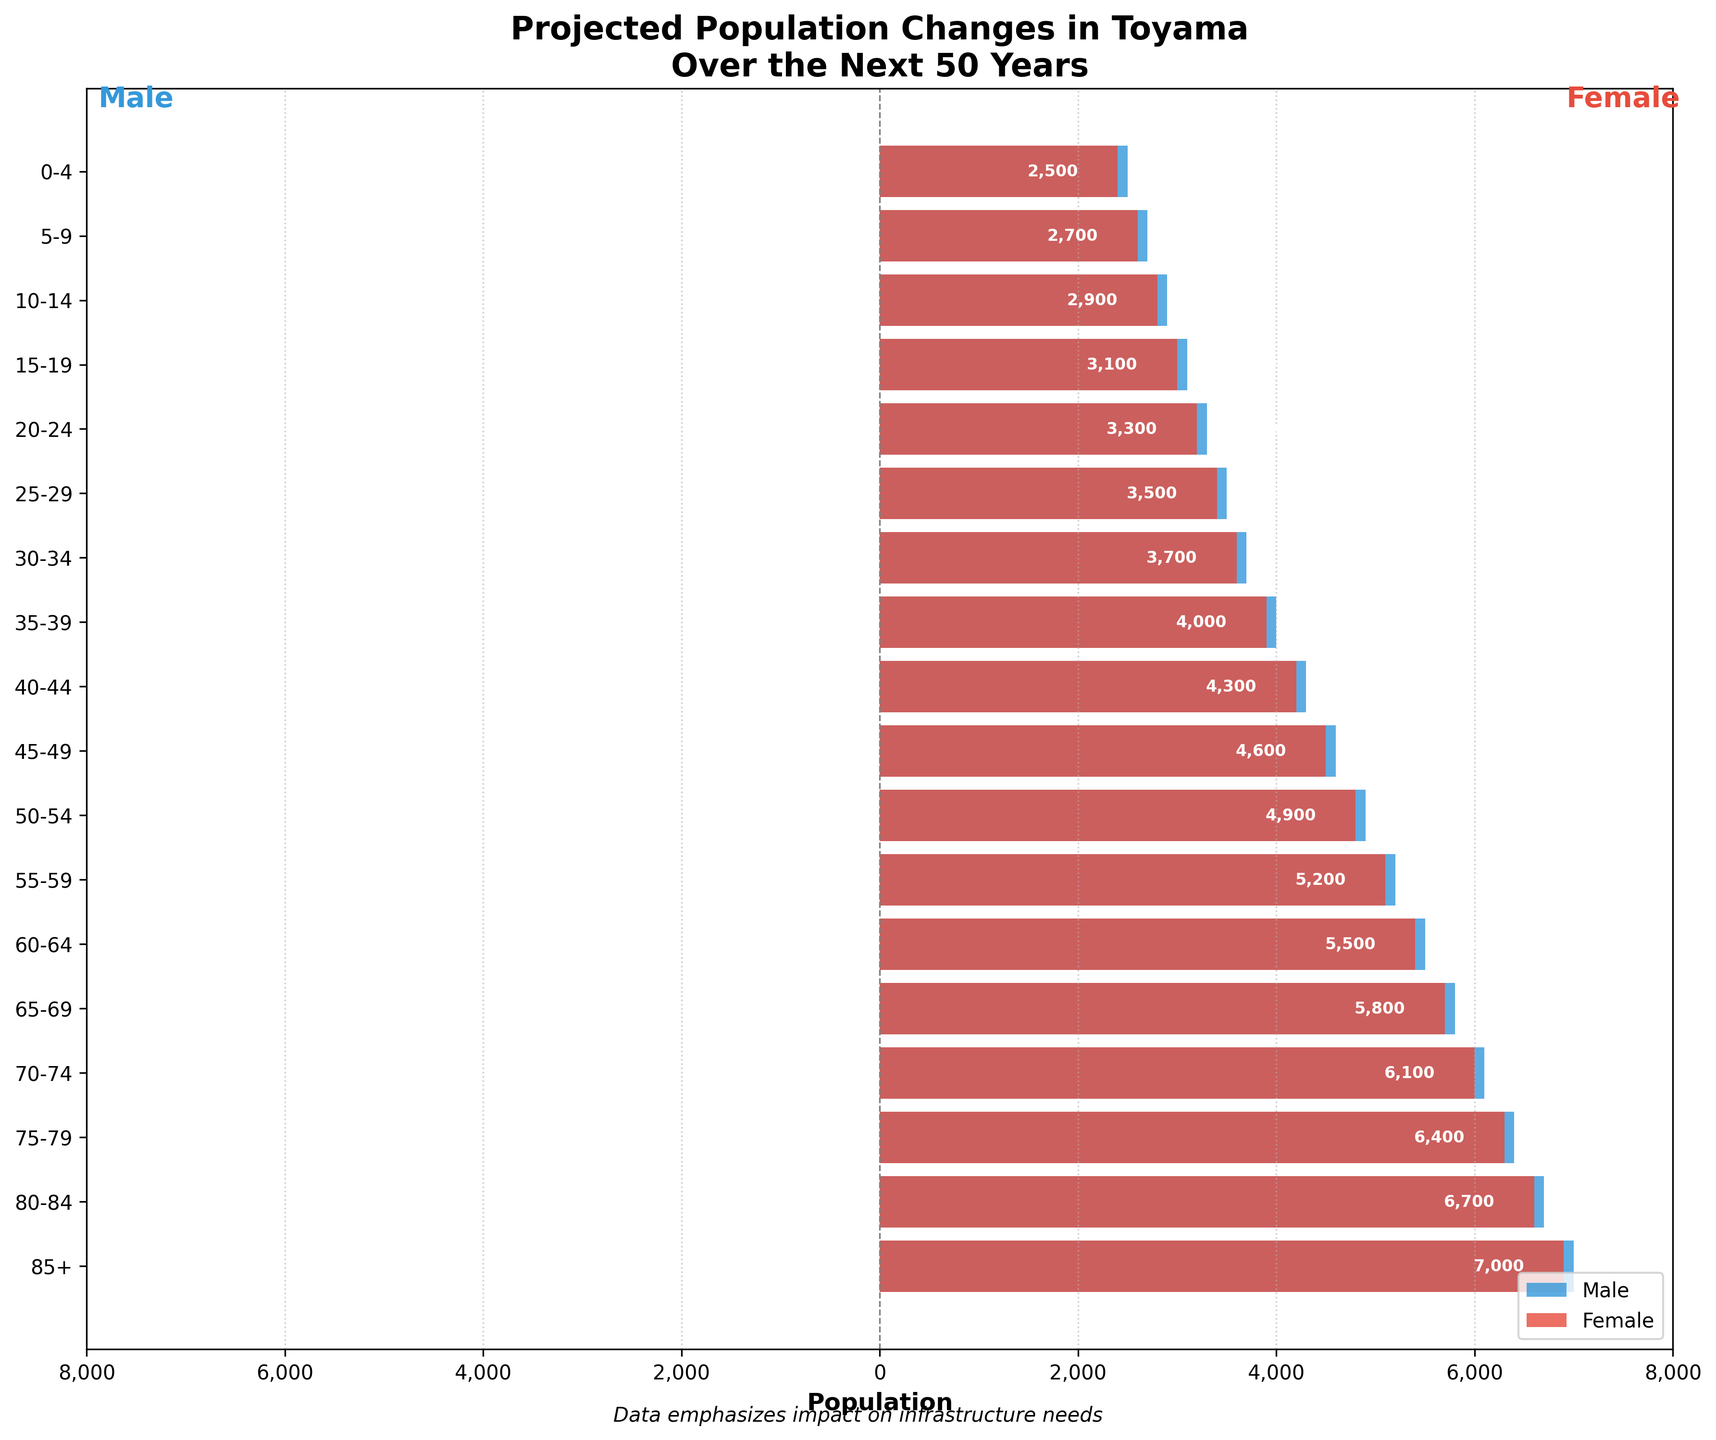What is the title of the figure? The title is usually displayed at the top of the figure.
Answer: Projected Population Changes in Toyama Over the Next 50 Years What is the population count for females in the age group 85+? Locate the bar corresponding to the age group 85+, then read the value at the end of the red (female) bar.
Answer: 6,900 How does the population of males in the 70-74 age group compare to that of females in the same age group? Locate the bars for the 70-74 age group. The left (blue) bar represents males and the right (red) bar represents females. The blue bar's value is -6,100, and the red bar's value is 6,000. The absolute values reveal the comparison.
Answer: Males have a slightly larger population than females Which age group has the highest population for males? Look at the length of the blue bars across all age groups. The longest blue bar corresponds to the age group with the highest male population.
Answer: 85+ Identify the age group that has nearly the same population for both males and females. Look for bars that are nearly equal in length across both genders. The age group 0-4, for example, has populations of -2,500 (males) and 2,400 (females).
Answer: 0-4 What is the total projected female population listed in the data? Sum all the female population values given: 2400 + 2600 + 2800 + 3000 + 3200 + 3400 + 3600 + 3900 + 4200 + 4500 + 4800 + 5100 + 5400 + 5700 + 6000 + 6300 + 6600 + 6900 = 95,900.
Answer: 95,900 What is the population trend for the male demographic with increasing age groups? Observe the blue bars' lengths from the bottom to the top. The bars get progressively longer, indicating an increasing male population with age.
Answer: Increasing with age Considering infrastructure impact, what age group might require the most healthcare facilities? Look at the population pyramid to determine which age group has the highest elderly population, as they are more likely to need healthcare. The 85+ age group has the highest population for both genders.
Answer: 85+ How would you describe the gender balance in the 15-19 age group? Compare the lengths of the blue (-3,100) and red (3,000) bars for this age group. They are quite similar, indicating a nearly balanced gender ratio.
Answer: Nearly balanced 